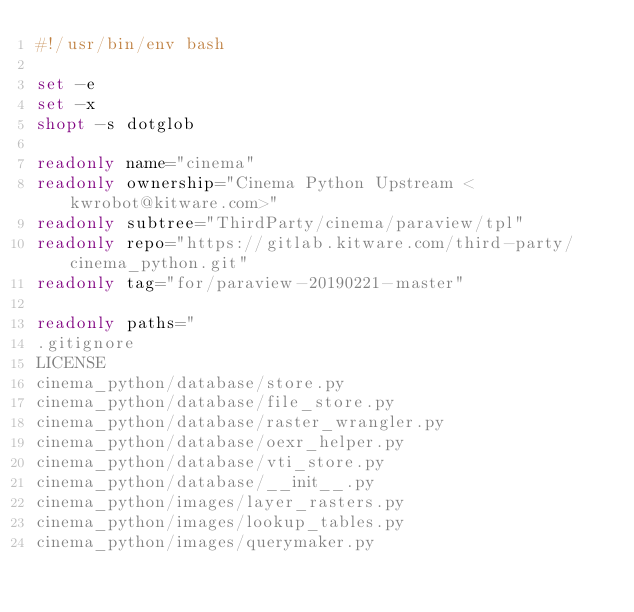<code> <loc_0><loc_0><loc_500><loc_500><_Bash_>#!/usr/bin/env bash

set -e
set -x
shopt -s dotglob

readonly name="cinema"
readonly ownership="Cinema Python Upstream <kwrobot@kitware.com>"
readonly subtree="ThirdParty/cinema/paraview/tpl"
readonly repo="https://gitlab.kitware.com/third-party/cinema_python.git"
readonly tag="for/paraview-20190221-master"

readonly paths="
.gitignore
LICENSE
cinema_python/database/store.py
cinema_python/database/file_store.py
cinema_python/database/raster_wrangler.py
cinema_python/database/oexr_helper.py
cinema_python/database/vti_store.py
cinema_python/database/__init__.py
cinema_python/images/layer_rasters.py
cinema_python/images/lookup_tables.py
cinema_python/images/querymaker.py</code> 